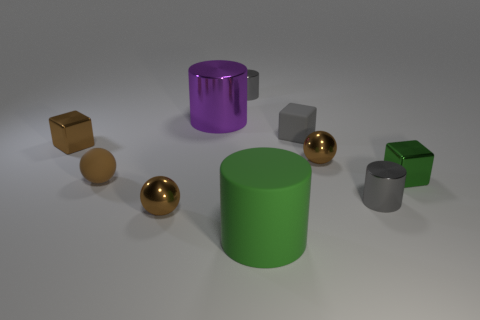Subtract all cylinders. How many objects are left? 6 Add 6 gray metal objects. How many gray metal objects exist? 8 Subtract 0 cyan cylinders. How many objects are left? 10 Subtract all big purple objects. Subtract all gray cubes. How many objects are left? 8 Add 2 brown metallic objects. How many brown metallic objects are left? 5 